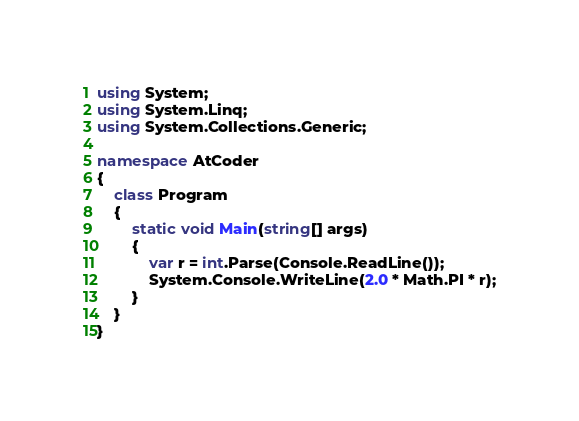<code> <loc_0><loc_0><loc_500><loc_500><_C#_>using System;
using System.Linq;
using System.Collections.Generic;

namespace AtCoder
{
    class Program
    {
        static void Main(string[] args)
        {
            var r = int.Parse(Console.ReadLine());
            System.Console.WriteLine(2.0 * Math.PI * r);
        }
    }
}</code> 